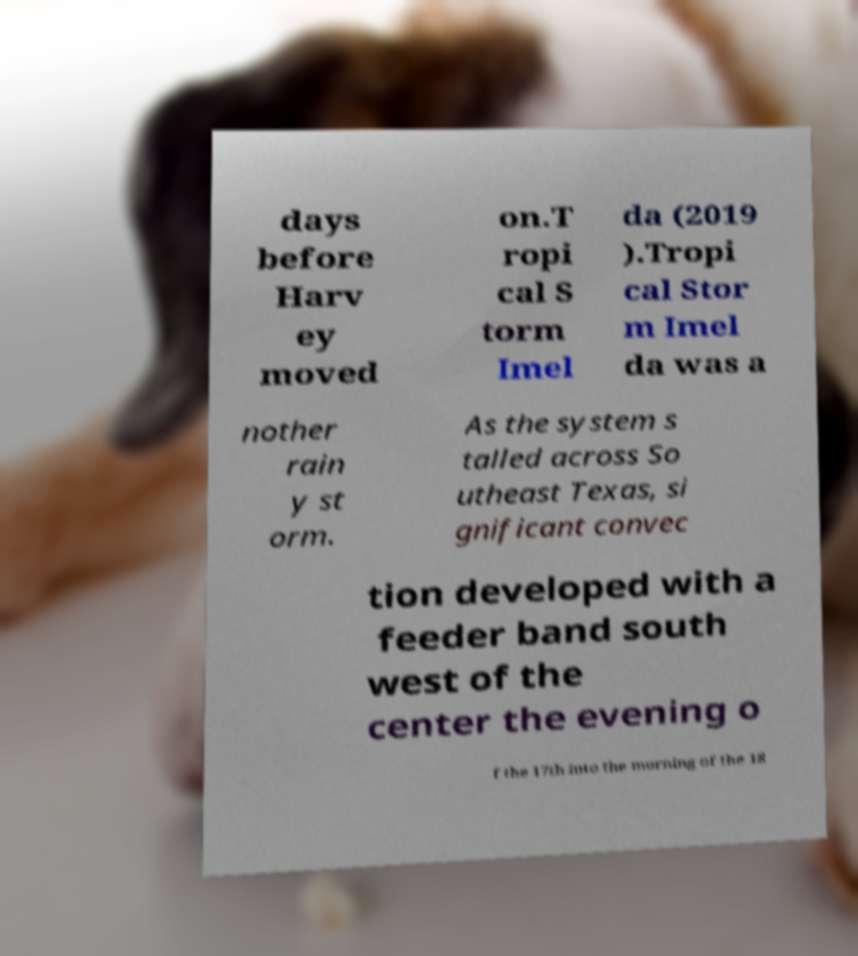Please read and relay the text visible in this image. What does it say? days before Harv ey moved on.T ropi cal S torm Imel da (2019 ).Tropi cal Stor m Imel da was a nother rain y st orm. As the system s talled across So utheast Texas, si gnificant convec tion developed with a feeder band south west of the center the evening o f the 17th into the morning of the 18 